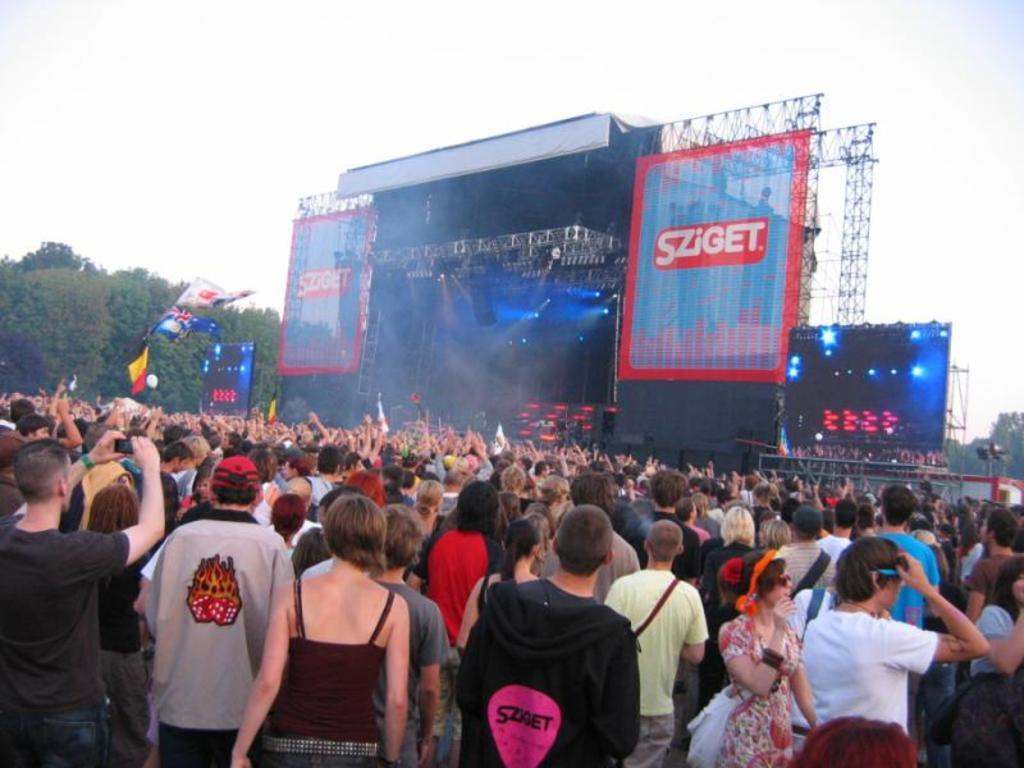What are the people in the image doing? The persons standing on the ground in the image are likely attending an event or gathering. What can be seen in the background of the image? There is a stage, two huge banners, a huge screen, trees, flags, and the sky visible in the background of the image. How many banners are present in the background of the image? There are two huge banners in the background of the image. What type of sweater is the person in the image wearing? There is no person wearing a sweater in the image; the persons are standing on the ground without any visible clothing items mentioned. 